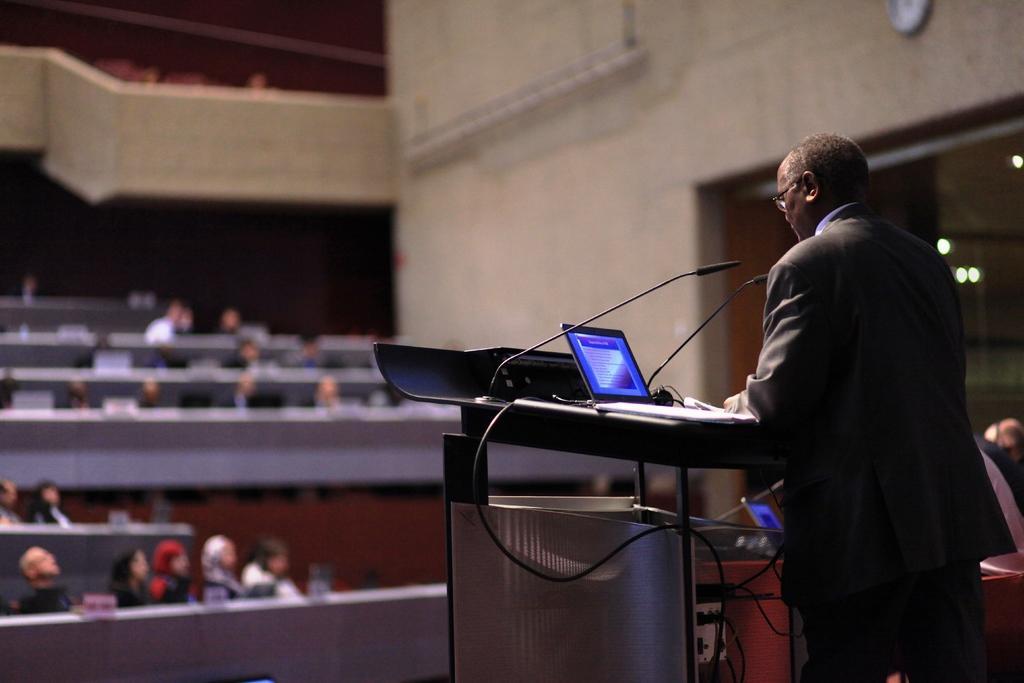Could you give a brief overview of what you see in this image? In this image there is a person standing in front of the table. On the table there are mics, laptop and a book, in front of him there are a few people seated on their seats, which are blurred. In the background there is a clock hanging on the wall. 